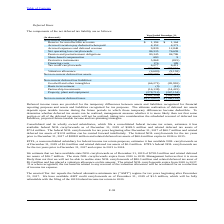According to Consolidated Communications Holdings's financial document, What is the Reserve for uncollectible accounts for 2018? According to the financial document, $1,164 (in thousands). The relevant text states: "Reserve for uncollectible accounts $ 1,194 $ 1,164..." Also, What determine whether deferred tax assets can be realized or not realized? taking into consideration the scheduled reversal of deferred tax liabilities, projected future taxable income and tax-planning strategies.. The document states: "l of the deferred tax assets will not be realized, taking into consideration the scheduled reversal of deferred tax liabilities, projected future taxa..." Also, What was available state tax credit carryforwards as of December 31, 2019? Based on the financial document, the answer is we have available state tax credit carryforwards as of December 31, 2019 of $7.7 million and related deferred tax assets of $6.1 million. Also, can you calculate: What is the increase/ (decrease) in Reserve for uncollectible accounts from 2018 to 2019? Based on the calculation: 1,194-1,164, the result is 30 (in thousands). This is based on the information: "Reserve for uncollectible accounts $ 1,194 $ 1,164 Reserve for uncollectible accounts $ 1,194 $ 1,164..." The key data points involved are: 1,164, 1,194. Also, can you calculate: What is the increase/ (decrease) in Accrued vacation pay deducted when paid from 2018 to 2019? Based on the calculation: 4,152-4,371, the result is -219 (in thousands). This is based on the information: "Accrued vacation pay deducted when paid 4,152 4,371 Accrued vacation pay deducted when paid 4,152 4,371..." The key data points involved are: 4,152, 4,371. Also, can you calculate: What is the increase/ (decrease) in Accrued expenses and deferred revenue from 2018 to 2019? Based on the calculation: 9,839-12,848, the result is -3009 (in thousands). This is based on the information: "Accrued expenses and deferred revenue 9,839 12,848 Accrued expenses and deferred revenue 9,839 12,848..." The key data points involved are: 12,848, 9,839. 